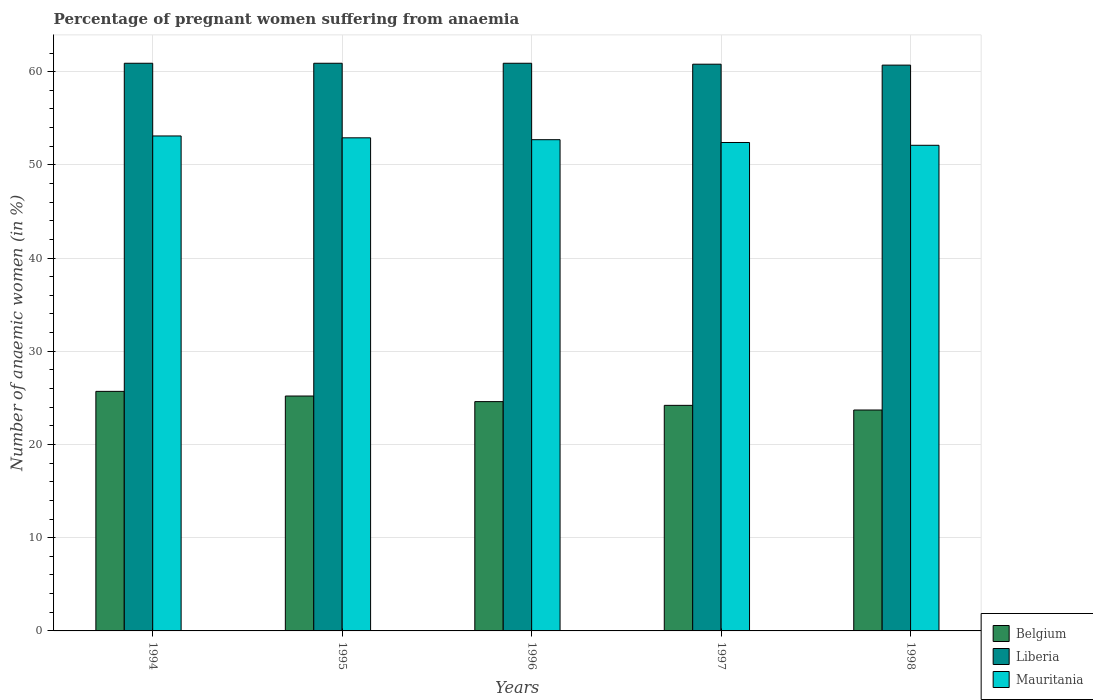Are the number of bars on each tick of the X-axis equal?
Your answer should be very brief. Yes. In how many cases, is the number of bars for a given year not equal to the number of legend labels?
Keep it short and to the point. 0. What is the number of anaemic women in Mauritania in 1998?
Your answer should be very brief. 52.1. Across all years, what is the maximum number of anaemic women in Liberia?
Offer a terse response. 60.9. Across all years, what is the minimum number of anaemic women in Mauritania?
Provide a short and direct response. 52.1. What is the total number of anaemic women in Mauritania in the graph?
Provide a short and direct response. 263.2. What is the difference between the number of anaemic women in Liberia in 1994 and that in 1997?
Keep it short and to the point. 0.1. What is the difference between the number of anaemic women in Mauritania in 1998 and the number of anaemic women in Belgium in 1997?
Your response must be concise. 27.9. What is the average number of anaemic women in Liberia per year?
Make the answer very short. 60.84. In the year 1998, what is the difference between the number of anaemic women in Belgium and number of anaemic women in Mauritania?
Make the answer very short. -28.4. In how many years, is the number of anaemic women in Mauritania greater than 36 %?
Your response must be concise. 5. What is the ratio of the number of anaemic women in Liberia in 1996 to that in 1998?
Offer a terse response. 1. Is the number of anaemic women in Mauritania in 1997 less than that in 1998?
Provide a succinct answer. No. What is the difference between the highest and the second highest number of anaemic women in Belgium?
Your response must be concise. 0.5. In how many years, is the number of anaemic women in Belgium greater than the average number of anaemic women in Belgium taken over all years?
Offer a terse response. 2. What does the 1st bar from the left in 1995 represents?
Your response must be concise. Belgium. What does the 2nd bar from the right in 1998 represents?
Your response must be concise. Liberia. How many bars are there?
Ensure brevity in your answer.  15. What is the difference between two consecutive major ticks on the Y-axis?
Make the answer very short. 10. Are the values on the major ticks of Y-axis written in scientific E-notation?
Give a very brief answer. No. Does the graph contain any zero values?
Offer a terse response. No. Does the graph contain grids?
Give a very brief answer. Yes. How are the legend labels stacked?
Offer a very short reply. Vertical. What is the title of the graph?
Offer a terse response. Percentage of pregnant women suffering from anaemia. What is the label or title of the X-axis?
Your answer should be very brief. Years. What is the label or title of the Y-axis?
Ensure brevity in your answer.  Number of anaemic women (in %). What is the Number of anaemic women (in %) in Belgium in 1994?
Provide a short and direct response. 25.7. What is the Number of anaemic women (in %) in Liberia in 1994?
Make the answer very short. 60.9. What is the Number of anaemic women (in %) in Mauritania in 1994?
Keep it short and to the point. 53.1. What is the Number of anaemic women (in %) of Belgium in 1995?
Your answer should be compact. 25.2. What is the Number of anaemic women (in %) of Liberia in 1995?
Offer a very short reply. 60.9. What is the Number of anaemic women (in %) of Mauritania in 1995?
Your response must be concise. 52.9. What is the Number of anaemic women (in %) of Belgium in 1996?
Offer a very short reply. 24.6. What is the Number of anaemic women (in %) in Liberia in 1996?
Provide a short and direct response. 60.9. What is the Number of anaemic women (in %) of Mauritania in 1996?
Ensure brevity in your answer.  52.7. What is the Number of anaemic women (in %) of Belgium in 1997?
Give a very brief answer. 24.2. What is the Number of anaemic women (in %) of Liberia in 1997?
Keep it short and to the point. 60.8. What is the Number of anaemic women (in %) of Mauritania in 1997?
Offer a terse response. 52.4. What is the Number of anaemic women (in %) in Belgium in 1998?
Keep it short and to the point. 23.7. What is the Number of anaemic women (in %) in Liberia in 1998?
Your response must be concise. 60.7. What is the Number of anaemic women (in %) in Mauritania in 1998?
Your answer should be very brief. 52.1. Across all years, what is the maximum Number of anaemic women (in %) in Belgium?
Your answer should be very brief. 25.7. Across all years, what is the maximum Number of anaemic women (in %) in Liberia?
Offer a very short reply. 60.9. Across all years, what is the maximum Number of anaemic women (in %) of Mauritania?
Give a very brief answer. 53.1. Across all years, what is the minimum Number of anaemic women (in %) in Belgium?
Give a very brief answer. 23.7. Across all years, what is the minimum Number of anaemic women (in %) in Liberia?
Give a very brief answer. 60.7. Across all years, what is the minimum Number of anaemic women (in %) in Mauritania?
Give a very brief answer. 52.1. What is the total Number of anaemic women (in %) in Belgium in the graph?
Keep it short and to the point. 123.4. What is the total Number of anaemic women (in %) in Liberia in the graph?
Your response must be concise. 304.2. What is the total Number of anaemic women (in %) in Mauritania in the graph?
Keep it short and to the point. 263.2. What is the difference between the Number of anaemic women (in %) of Liberia in 1994 and that in 1995?
Make the answer very short. 0. What is the difference between the Number of anaemic women (in %) of Mauritania in 1994 and that in 1996?
Your response must be concise. 0.4. What is the difference between the Number of anaemic women (in %) of Mauritania in 1994 and that in 1997?
Your answer should be very brief. 0.7. What is the difference between the Number of anaemic women (in %) of Belgium in 1994 and that in 1998?
Offer a very short reply. 2. What is the difference between the Number of anaemic women (in %) of Belgium in 1995 and that in 1996?
Provide a succinct answer. 0.6. What is the difference between the Number of anaemic women (in %) in Liberia in 1995 and that in 1996?
Your answer should be compact. 0. What is the difference between the Number of anaemic women (in %) in Mauritania in 1995 and that in 1996?
Provide a succinct answer. 0.2. What is the difference between the Number of anaemic women (in %) of Belgium in 1995 and that in 1997?
Offer a terse response. 1. What is the difference between the Number of anaemic women (in %) of Mauritania in 1995 and that in 1997?
Your answer should be very brief. 0.5. What is the difference between the Number of anaemic women (in %) in Belgium in 1995 and that in 1998?
Provide a succinct answer. 1.5. What is the difference between the Number of anaemic women (in %) in Mauritania in 1995 and that in 1998?
Give a very brief answer. 0.8. What is the difference between the Number of anaemic women (in %) of Belgium in 1996 and that in 1997?
Your answer should be compact. 0.4. What is the difference between the Number of anaemic women (in %) in Mauritania in 1996 and that in 1997?
Make the answer very short. 0.3. What is the difference between the Number of anaemic women (in %) of Belgium in 1996 and that in 1998?
Your response must be concise. 0.9. What is the difference between the Number of anaemic women (in %) of Liberia in 1996 and that in 1998?
Offer a terse response. 0.2. What is the difference between the Number of anaemic women (in %) in Mauritania in 1996 and that in 1998?
Keep it short and to the point. 0.6. What is the difference between the Number of anaemic women (in %) in Belgium in 1997 and that in 1998?
Keep it short and to the point. 0.5. What is the difference between the Number of anaemic women (in %) in Liberia in 1997 and that in 1998?
Make the answer very short. 0.1. What is the difference between the Number of anaemic women (in %) of Belgium in 1994 and the Number of anaemic women (in %) of Liberia in 1995?
Make the answer very short. -35.2. What is the difference between the Number of anaemic women (in %) in Belgium in 1994 and the Number of anaemic women (in %) in Mauritania in 1995?
Provide a short and direct response. -27.2. What is the difference between the Number of anaemic women (in %) in Belgium in 1994 and the Number of anaemic women (in %) in Liberia in 1996?
Provide a short and direct response. -35.2. What is the difference between the Number of anaemic women (in %) in Belgium in 1994 and the Number of anaemic women (in %) in Liberia in 1997?
Offer a terse response. -35.1. What is the difference between the Number of anaemic women (in %) in Belgium in 1994 and the Number of anaemic women (in %) in Mauritania in 1997?
Your response must be concise. -26.7. What is the difference between the Number of anaemic women (in %) in Belgium in 1994 and the Number of anaemic women (in %) in Liberia in 1998?
Your response must be concise. -35. What is the difference between the Number of anaemic women (in %) of Belgium in 1994 and the Number of anaemic women (in %) of Mauritania in 1998?
Offer a terse response. -26.4. What is the difference between the Number of anaemic women (in %) in Belgium in 1995 and the Number of anaemic women (in %) in Liberia in 1996?
Make the answer very short. -35.7. What is the difference between the Number of anaemic women (in %) in Belgium in 1995 and the Number of anaemic women (in %) in Mauritania in 1996?
Provide a short and direct response. -27.5. What is the difference between the Number of anaemic women (in %) of Belgium in 1995 and the Number of anaemic women (in %) of Liberia in 1997?
Provide a short and direct response. -35.6. What is the difference between the Number of anaemic women (in %) in Belgium in 1995 and the Number of anaemic women (in %) in Mauritania in 1997?
Provide a short and direct response. -27.2. What is the difference between the Number of anaemic women (in %) in Belgium in 1995 and the Number of anaemic women (in %) in Liberia in 1998?
Your answer should be very brief. -35.5. What is the difference between the Number of anaemic women (in %) in Belgium in 1995 and the Number of anaemic women (in %) in Mauritania in 1998?
Ensure brevity in your answer.  -26.9. What is the difference between the Number of anaemic women (in %) of Belgium in 1996 and the Number of anaemic women (in %) of Liberia in 1997?
Your response must be concise. -36.2. What is the difference between the Number of anaemic women (in %) of Belgium in 1996 and the Number of anaemic women (in %) of Mauritania in 1997?
Offer a very short reply. -27.8. What is the difference between the Number of anaemic women (in %) in Liberia in 1996 and the Number of anaemic women (in %) in Mauritania in 1997?
Your answer should be compact. 8.5. What is the difference between the Number of anaemic women (in %) in Belgium in 1996 and the Number of anaemic women (in %) in Liberia in 1998?
Your answer should be very brief. -36.1. What is the difference between the Number of anaemic women (in %) of Belgium in 1996 and the Number of anaemic women (in %) of Mauritania in 1998?
Provide a succinct answer. -27.5. What is the difference between the Number of anaemic women (in %) in Liberia in 1996 and the Number of anaemic women (in %) in Mauritania in 1998?
Offer a terse response. 8.8. What is the difference between the Number of anaemic women (in %) in Belgium in 1997 and the Number of anaemic women (in %) in Liberia in 1998?
Provide a succinct answer. -36.5. What is the difference between the Number of anaemic women (in %) of Belgium in 1997 and the Number of anaemic women (in %) of Mauritania in 1998?
Make the answer very short. -27.9. What is the average Number of anaemic women (in %) of Belgium per year?
Ensure brevity in your answer.  24.68. What is the average Number of anaemic women (in %) of Liberia per year?
Provide a succinct answer. 60.84. What is the average Number of anaemic women (in %) in Mauritania per year?
Offer a very short reply. 52.64. In the year 1994, what is the difference between the Number of anaemic women (in %) in Belgium and Number of anaemic women (in %) in Liberia?
Offer a terse response. -35.2. In the year 1994, what is the difference between the Number of anaemic women (in %) in Belgium and Number of anaemic women (in %) in Mauritania?
Your answer should be very brief. -27.4. In the year 1994, what is the difference between the Number of anaemic women (in %) of Liberia and Number of anaemic women (in %) of Mauritania?
Ensure brevity in your answer.  7.8. In the year 1995, what is the difference between the Number of anaemic women (in %) of Belgium and Number of anaemic women (in %) of Liberia?
Your answer should be compact. -35.7. In the year 1995, what is the difference between the Number of anaemic women (in %) of Belgium and Number of anaemic women (in %) of Mauritania?
Your answer should be compact. -27.7. In the year 1996, what is the difference between the Number of anaemic women (in %) of Belgium and Number of anaemic women (in %) of Liberia?
Keep it short and to the point. -36.3. In the year 1996, what is the difference between the Number of anaemic women (in %) of Belgium and Number of anaemic women (in %) of Mauritania?
Keep it short and to the point. -28.1. In the year 1997, what is the difference between the Number of anaemic women (in %) of Belgium and Number of anaemic women (in %) of Liberia?
Your answer should be very brief. -36.6. In the year 1997, what is the difference between the Number of anaemic women (in %) of Belgium and Number of anaemic women (in %) of Mauritania?
Your response must be concise. -28.2. In the year 1998, what is the difference between the Number of anaemic women (in %) of Belgium and Number of anaemic women (in %) of Liberia?
Ensure brevity in your answer.  -37. In the year 1998, what is the difference between the Number of anaemic women (in %) in Belgium and Number of anaemic women (in %) in Mauritania?
Ensure brevity in your answer.  -28.4. What is the ratio of the Number of anaemic women (in %) in Belgium in 1994 to that in 1995?
Make the answer very short. 1.02. What is the ratio of the Number of anaemic women (in %) of Belgium in 1994 to that in 1996?
Give a very brief answer. 1.04. What is the ratio of the Number of anaemic women (in %) in Mauritania in 1994 to that in 1996?
Make the answer very short. 1.01. What is the ratio of the Number of anaemic women (in %) in Belgium in 1994 to that in 1997?
Give a very brief answer. 1.06. What is the ratio of the Number of anaemic women (in %) of Liberia in 1994 to that in 1997?
Provide a short and direct response. 1. What is the ratio of the Number of anaemic women (in %) of Mauritania in 1994 to that in 1997?
Provide a short and direct response. 1.01. What is the ratio of the Number of anaemic women (in %) in Belgium in 1994 to that in 1998?
Offer a terse response. 1.08. What is the ratio of the Number of anaemic women (in %) of Liberia in 1994 to that in 1998?
Give a very brief answer. 1. What is the ratio of the Number of anaemic women (in %) of Mauritania in 1994 to that in 1998?
Provide a succinct answer. 1.02. What is the ratio of the Number of anaemic women (in %) of Belgium in 1995 to that in 1996?
Offer a very short reply. 1.02. What is the ratio of the Number of anaemic women (in %) in Liberia in 1995 to that in 1996?
Your response must be concise. 1. What is the ratio of the Number of anaemic women (in %) in Mauritania in 1995 to that in 1996?
Provide a succinct answer. 1. What is the ratio of the Number of anaemic women (in %) in Belgium in 1995 to that in 1997?
Provide a short and direct response. 1.04. What is the ratio of the Number of anaemic women (in %) of Liberia in 1995 to that in 1997?
Your answer should be very brief. 1. What is the ratio of the Number of anaemic women (in %) of Mauritania in 1995 to that in 1997?
Your answer should be very brief. 1.01. What is the ratio of the Number of anaemic women (in %) of Belgium in 1995 to that in 1998?
Give a very brief answer. 1.06. What is the ratio of the Number of anaemic women (in %) of Mauritania in 1995 to that in 1998?
Provide a short and direct response. 1.02. What is the ratio of the Number of anaemic women (in %) of Belgium in 1996 to that in 1997?
Make the answer very short. 1.02. What is the ratio of the Number of anaemic women (in %) in Liberia in 1996 to that in 1997?
Offer a terse response. 1. What is the ratio of the Number of anaemic women (in %) of Mauritania in 1996 to that in 1997?
Keep it short and to the point. 1.01. What is the ratio of the Number of anaemic women (in %) of Belgium in 1996 to that in 1998?
Your answer should be very brief. 1.04. What is the ratio of the Number of anaemic women (in %) in Mauritania in 1996 to that in 1998?
Your response must be concise. 1.01. What is the ratio of the Number of anaemic women (in %) of Belgium in 1997 to that in 1998?
Provide a succinct answer. 1.02. What is the ratio of the Number of anaemic women (in %) in Liberia in 1997 to that in 1998?
Offer a very short reply. 1. What is the difference between the highest and the lowest Number of anaemic women (in %) of Belgium?
Keep it short and to the point. 2. What is the difference between the highest and the lowest Number of anaemic women (in %) of Liberia?
Offer a terse response. 0.2. What is the difference between the highest and the lowest Number of anaemic women (in %) in Mauritania?
Keep it short and to the point. 1. 